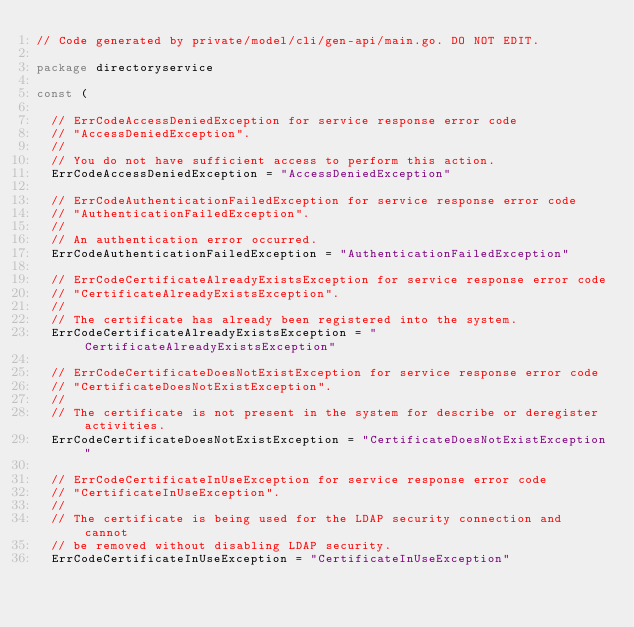<code> <loc_0><loc_0><loc_500><loc_500><_Go_>// Code generated by private/model/cli/gen-api/main.go. DO NOT EDIT.

package directoryservice

const (

	// ErrCodeAccessDeniedException for service response error code
	// "AccessDeniedException".
	//
	// You do not have sufficient access to perform this action.
	ErrCodeAccessDeniedException = "AccessDeniedException"

	// ErrCodeAuthenticationFailedException for service response error code
	// "AuthenticationFailedException".
	//
	// An authentication error occurred.
	ErrCodeAuthenticationFailedException = "AuthenticationFailedException"

	// ErrCodeCertificateAlreadyExistsException for service response error code
	// "CertificateAlreadyExistsException".
	//
	// The certificate has already been registered into the system.
	ErrCodeCertificateAlreadyExistsException = "CertificateAlreadyExistsException"

	// ErrCodeCertificateDoesNotExistException for service response error code
	// "CertificateDoesNotExistException".
	//
	// The certificate is not present in the system for describe or deregister activities.
	ErrCodeCertificateDoesNotExistException = "CertificateDoesNotExistException"

	// ErrCodeCertificateInUseException for service response error code
	// "CertificateInUseException".
	//
	// The certificate is being used for the LDAP security connection and cannot
	// be removed without disabling LDAP security.
	ErrCodeCertificateInUseException = "CertificateInUseException"
</code> 